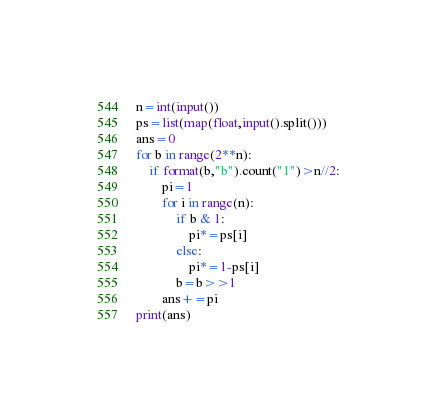Convert code to text. <code><loc_0><loc_0><loc_500><loc_500><_Python_>n=int(input())
ps=list(map(float,input().split()))
ans=0
for b in range(2**n):
    if format(b,"b").count("1")>n//2:
        pi=1
        for i in range(n):
            if b & 1:
                pi*=ps[i]
            else:
                pi*=1-ps[i]
            b=b>>1
        ans+=pi
print(ans)</code> 